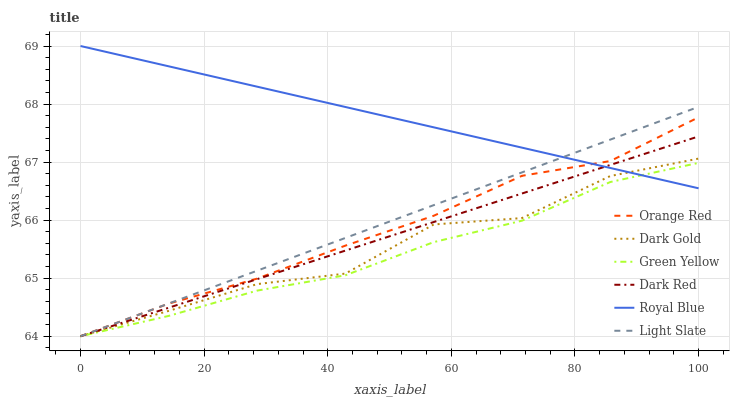Does Green Yellow have the minimum area under the curve?
Answer yes or no. Yes. Does Royal Blue have the maximum area under the curve?
Answer yes or no. Yes. Does Light Slate have the minimum area under the curve?
Answer yes or no. No. Does Light Slate have the maximum area under the curve?
Answer yes or no. No. Is Royal Blue the smoothest?
Answer yes or no. Yes. Is Dark Gold the roughest?
Answer yes or no. Yes. Is Light Slate the smoothest?
Answer yes or no. No. Is Light Slate the roughest?
Answer yes or no. No. Does Light Slate have the lowest value?
Answer yes or no. Yes. Does Royal Blue have the lowest value?
Answer yes or no. No. Does Royal Blue have the highest value?
Answer yes or no. Yes. Does Light Slate have the highest value?
Answer yes or no. No. Is Green Yellow less than Dark Gold?
Answer yes or no. Yes. Is Dark Gold greater than Green Yellow?
Answer yes or no. Yes. Does Light Slate intersect Royal Blue?
Answer yes or no. Yes. Is Light Slate less than Royal Blue?
Answer yes or no. No. Is Light Slate greater than Royal Blue?
Answer yes or no. No. Does Green Yellow intersect Dark Gold?
Answer yes or no. No. 